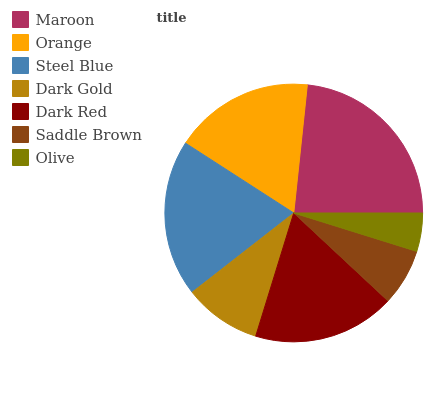Is Olive the minimum?
Answer yes or no. Yes. Is Maroon the maximum?
Answer yes or no. Yes. Is Orange the minimum?
Answer yes or no. No. Is Orange the maximum?
Answer yes or no. No. Is Maroon greater than Orange?
Answer yes or no. Yes. Is Orange less than Maroon?
Answer yes or no. Yes. Is Orange greater than Maroon?
Answer yes or no. No. Is Maroon less than Orange?
Answer yes or no. No. Is Orange the high median?
Answer yes or no. Yes. Is Orange the low median?
Answer yes or no. Yes. Is Saddle Brown the high median?
Answer yes or no. No. Is Maroon the low median?
Answer yes or no. No. 